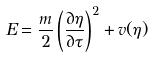<formula> <loc_0><loc_0><loc_500><loc_500>E = \frac { m } { 2 } \left ( \frac { \partial \eta } { \partial \tau } \right ) ^ { 2 } + v ( \eta )</formula> 